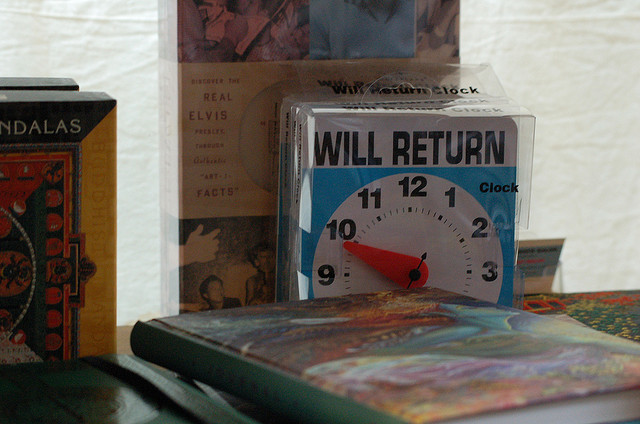<image>What does the last word on the sticker? I am not sure what the last word on the sticker is. It could be either 'return' or 'clock'. What does the last word on the sticker? I don't know what the last word on the sticker is. It can be seen 'return' or 'clock'. 